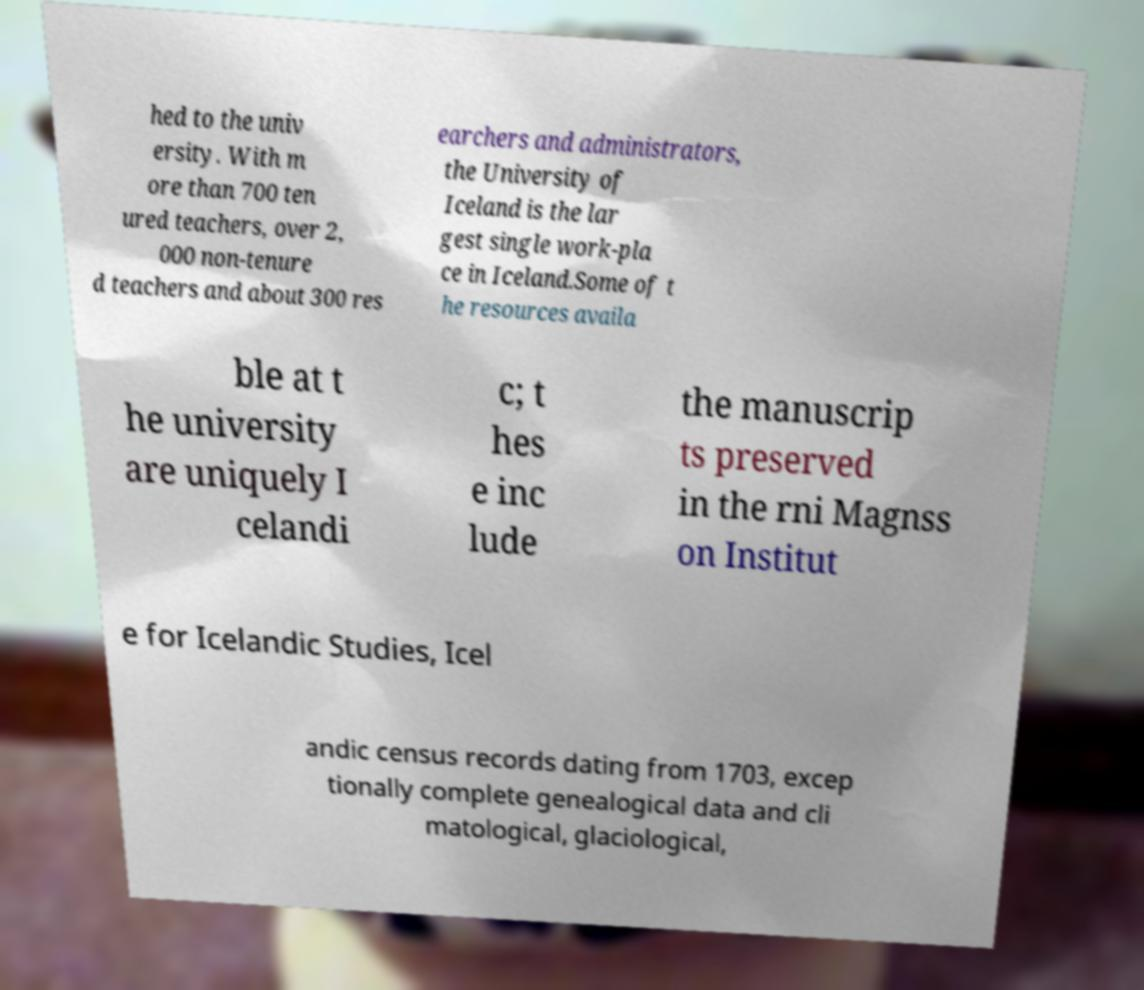What messages or text are displayed in this image? I need them in a readable, typed format. hed to the univ ersity. With m ore than 700 ten ured teachers, over 2, 000 non-tenure d teachers and about 300 res earchers and administrators, the University of Iceland is the lar gest single work-pla ce in Iceland.Some of t he resources availa ble at t he university are uniquely I celandi c; t hes e inc lude the manuscrip ts preserved in the rni Magnss on Institut e for Icelandic Studies, Icel andic census records dating from 1703, excep tionally complete genealogical data and cli matological, glaciological, 